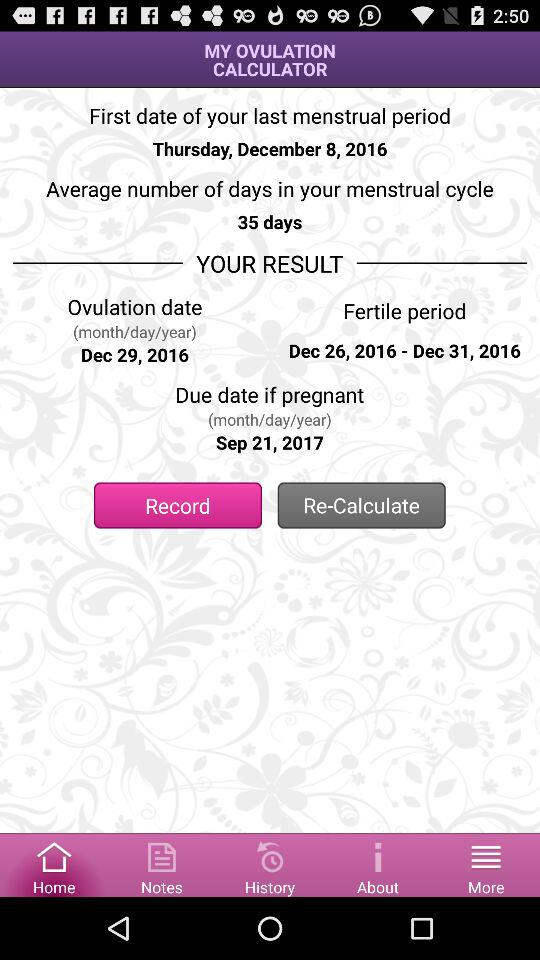What is the fertile date? The fertile date is from December 26, 2016 to December 31, 2016. 